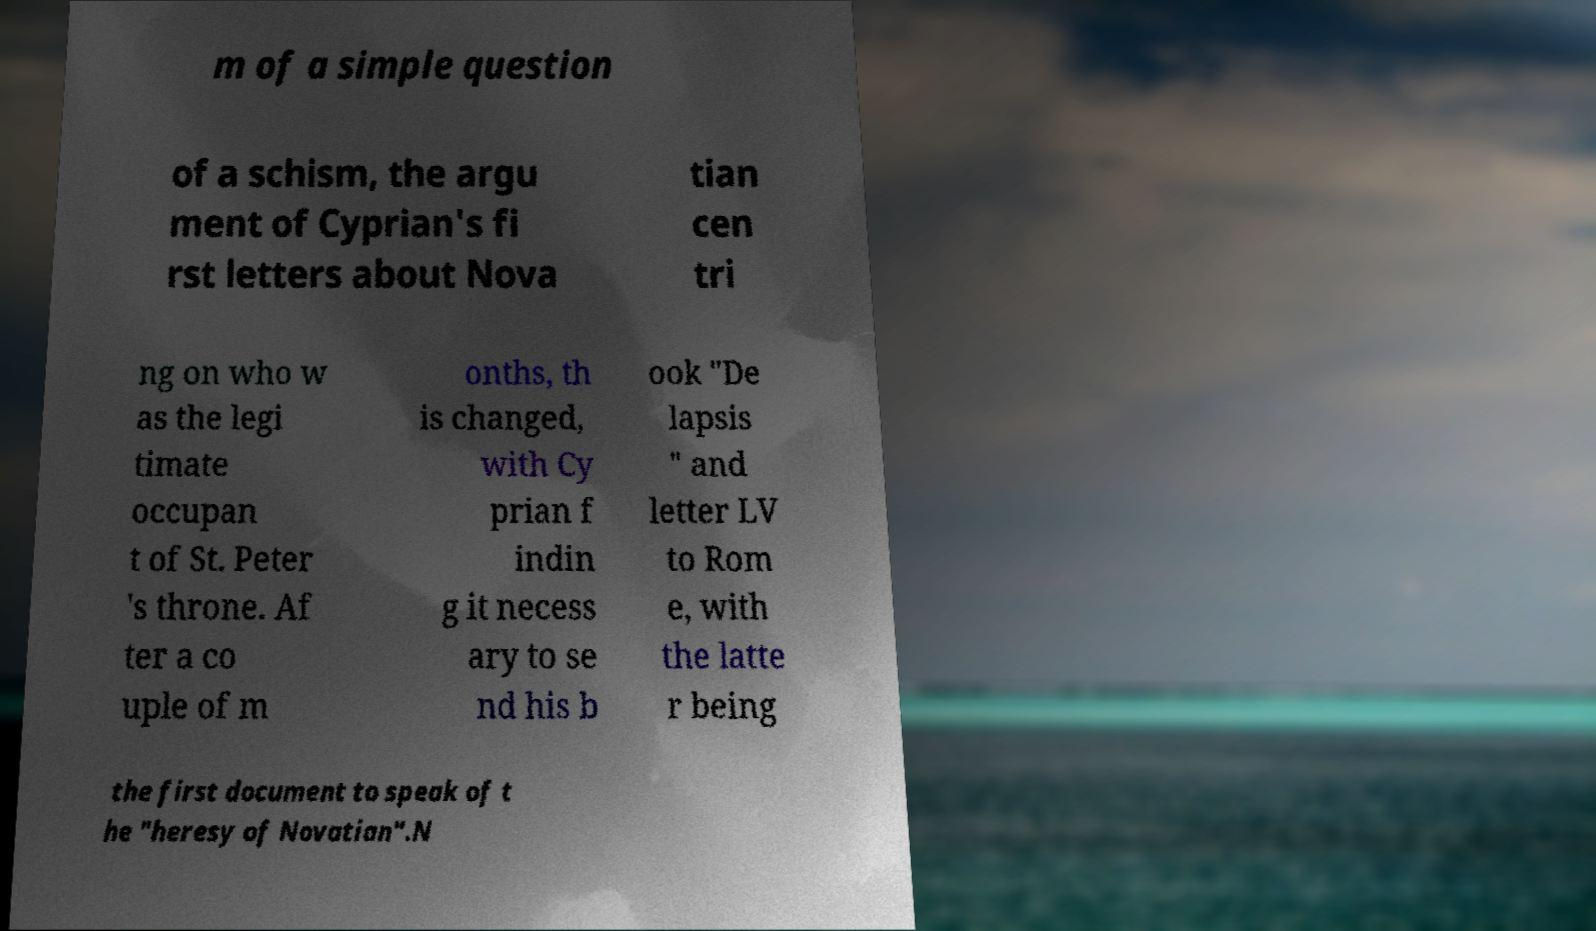I need the written content from this picture converted into text. Can you do that? m of a simple question of a schism, the argu ment of Cyprian's fi rst letters about Nova tian cen tri ng on who w as the legi timate occupan t of St. Peter 's throne. Af ter a co uple of m onths, th is changed, with Cy prian f indin g it necess ary to se nd his b ook "De lapsis " and letter LV to Rom e, with the latte r being the first document to speak of t he "heresy of Novatian".N 